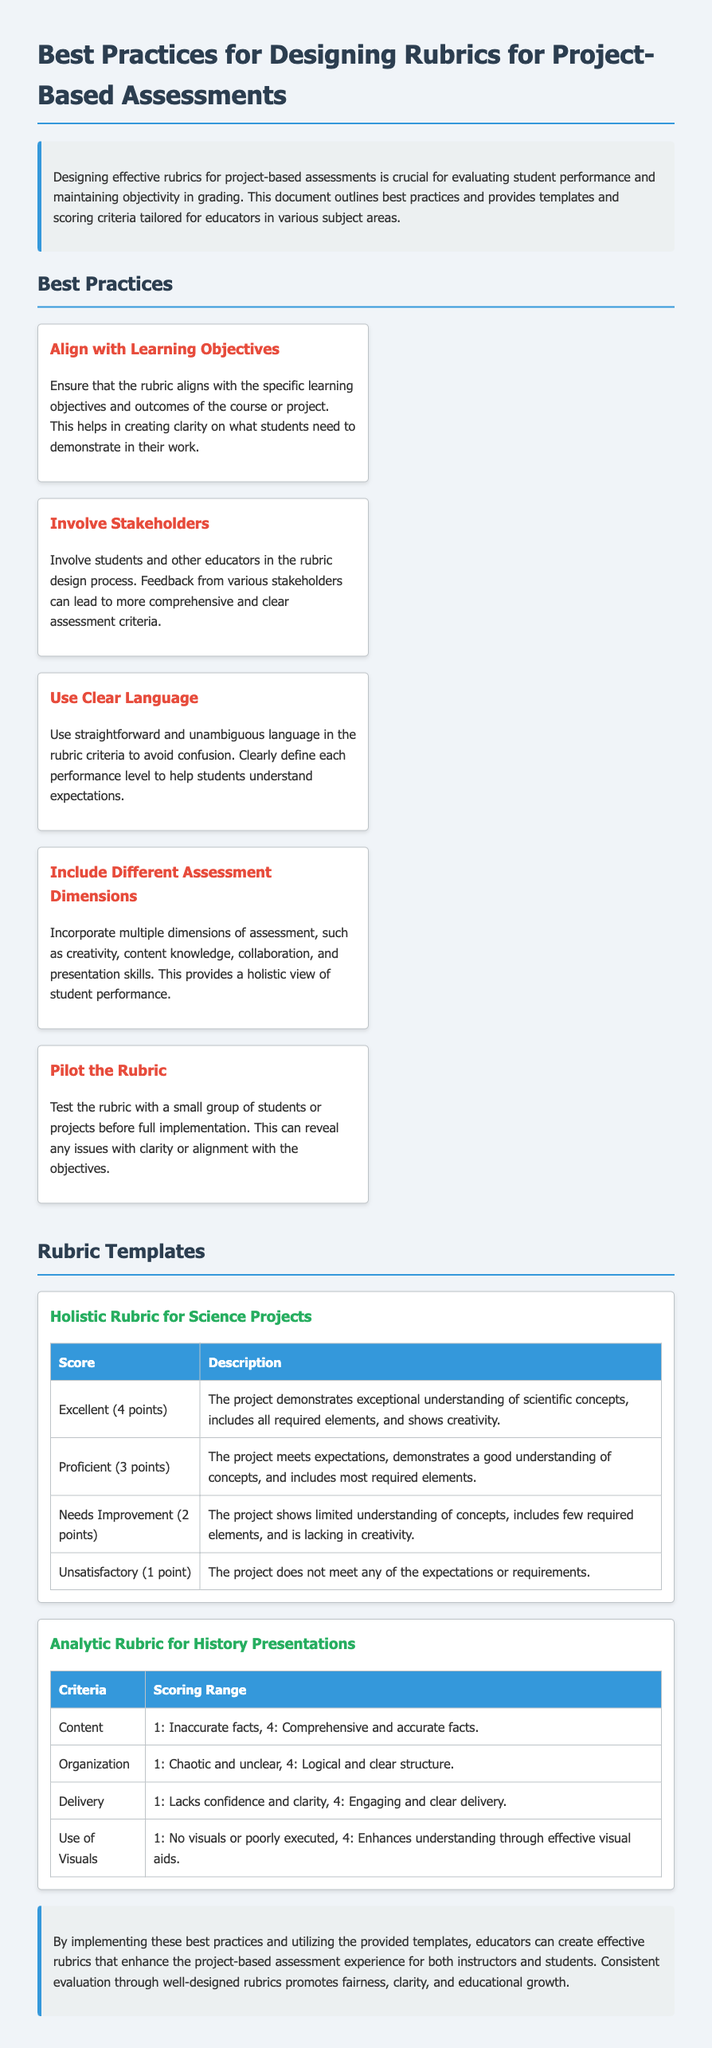what is the first best practice for designing rubrics? The first best practice mentioned is to ensure that the rubric aligns with the specific learning objectives and outcomes of the course or project.
Answer: Align with Learning Objectives how many points are awarded for an Excellent score in the Holistic Rubric for Science Projects? The Excellent score in the Holistic Rubric is given 4 points.
Answer: 4 points who should be involved in the rubric design process according to the document? The document suggests involving students and other educators in the rubric design process.
Answer: Students and other educators what is one aspect that the Analytic Rubric for History Presentations assesses? The Analytic Rubric assesses aspects like Content, Organization, Delivery, and Use of Visuals.
Answer: Content what is the maximum score in the Analytic Rubric for History Presentations? The maximum score across the criteria in the Analytic Rubric is 4 points.
Answer: 4 points what type of rubric is included for science projects? The document includes a Holistic Rubric for Science Projects.
Answer: Holistic Rubric how many best practices are listed in the document? There are five best practices listed for designing rubrics.
Answer: Five what is the main focus of the document? The main focus is on designing effective rubrics for project-based assessments.
Answer: Designing effective rubrics 